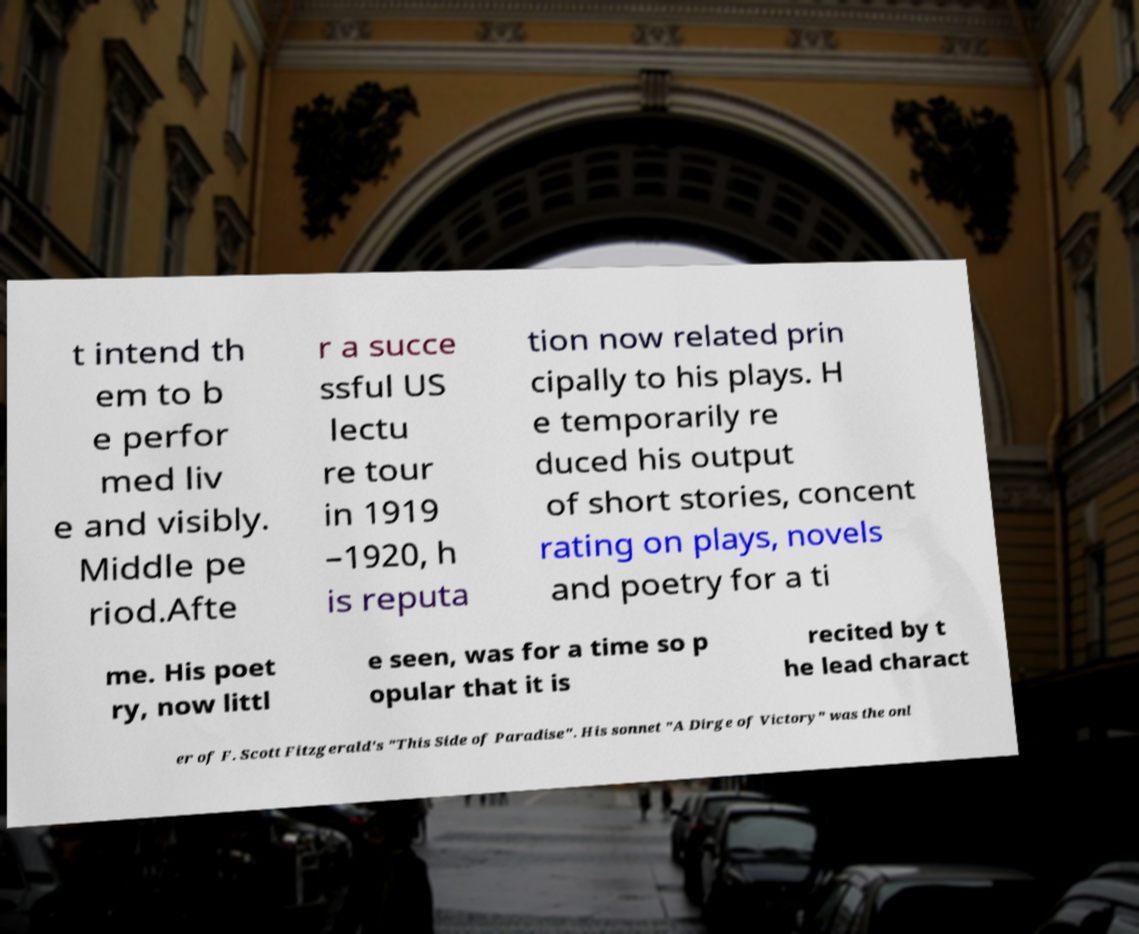Please read and relay the text visible in this image. What does it say? t intend th em to b e perfor med liv e and visibly. Middle pe riod.Afte r a succe ssful US lectu re tour in 1919 –1920, h is reputa tion now related prin cipally to his plays. H e temporarily re duced his output of short stories, concent rating on plays, novels and poetry for a ti me. His poet ry, now littl e seen, was for a time so p opular that it is recited by t he lead charact er of F. Scott Fitzgerald's "This Side of Paradise". His sonnet "A Dirge of Victory" was the onl 